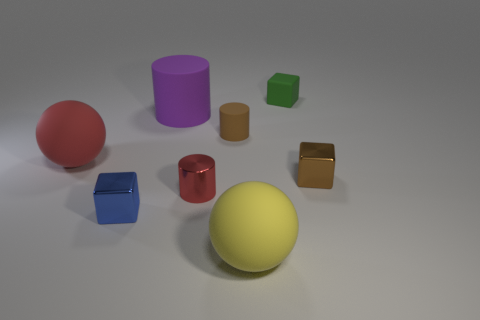Subtract all matte cubes. How many cubes are left? 2 Add 1 brown rubber objects. How many objects exist? 9 Subtract all cylinders. How many objects are left? 5 Subtract all green matte objects. Subtract all yellow rubber objects. How many objects are left? 6 Add 8 big rubber balls. How many big rubber balls are left? 10 Add 6 blocks. How many blocks exist? 9 Subtract 0 purple spheres. How many objects are left? 8 